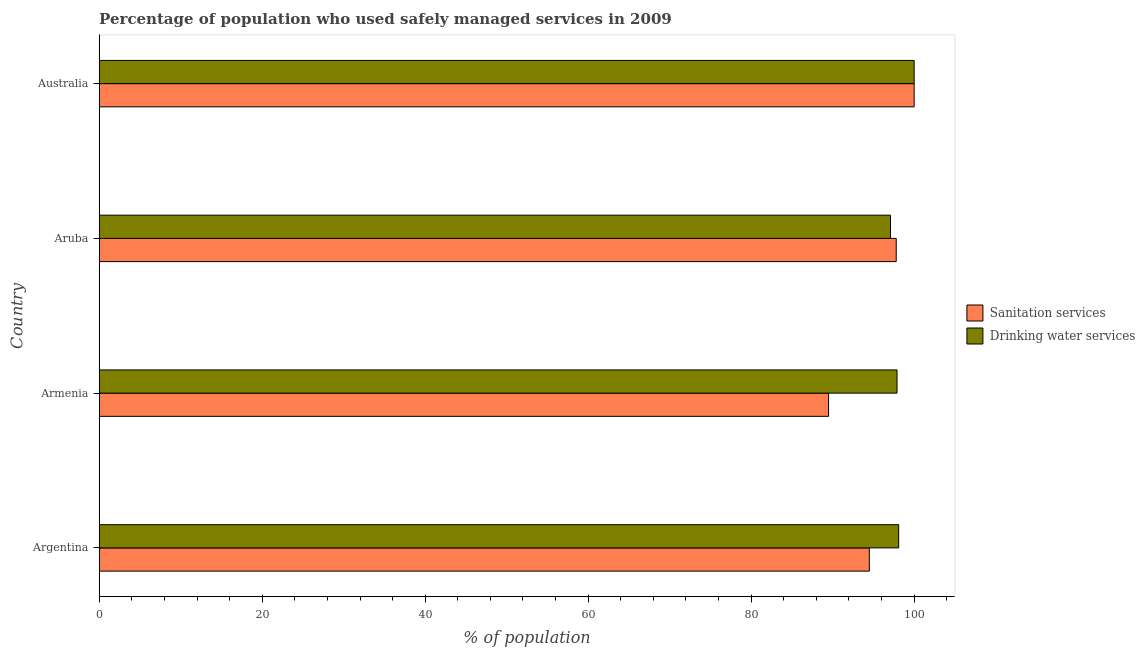How many different coloured bars are there?
Offer a very short reply. 2. Are the number of bars on each tick of the Y-axis equal?
Your response must be concise. Yes. What is the label of the 3rd group of bars from the top?
Provide a short and direct response. Armenia. In how many cases, is the number of bars for a given country not equal to the number of legend labels?
Ensure brevity in your answer.  0. What is the percentage of population who used sanitation services in Armenia?
Provide a short and direct response. 89.5. Across all countries, what is the minimum percentage of population who used sanitation services?
Your answer should be compact. 89.5. In which country was the percentage of population who used drinking water services minimum?
Make the answer very short. Aruba. What is the total percentage of population who used drinking water services in the graph?
Ensure brevity in your answer.  393.1. What is the difference between the percentage of population who used sanitation services in Argentina and the percentage of population who used drinking water services in Armenia?
Ensure brevity in your answer.  -3.4. What is the average percentage of population who used sanitation services per country?
Your response must be concise. 95.45. In how many countries, is the percentage of population who used drinking water services greater than 40 %?
Your answer should be very brief. 4. What is the ratio of the percentage of population who used sanitation services in Armenia to that in Aruba?
Your answer should be very brief. 0.92. Is the percentage of population who used sanitation services in Argentina less than that in Armenia?
Keep it short and to the point. No. What is the difference between the highest and the second highest percentage of population who used sanitation services?
Offer a very short reply. 2.2. What is the difference between the highest and the lowest percentage of population who used drinking water services?
Give a very brief answer. 2.9. In how many countries, is the percentage of population who used sanitation services greater than the average percentage of population who used sanitation services taken over all countries?
Ensure brevity in your answer.  2. What does the 2nd bar from the top in Aruba represents?
Your response must be concise. Sanitation services. What does the 1st bar from the bottom in Argentina represents?
Your answer should be compact. Sanitation services. Are all the bars in the graph horizontal?
Make the answer very short. Yes. Where does the legend appear in the graph?
Offer a terse response. Center right. What is the title of the graph?
Provide a succinct answer. Percentage of population who used safely managed services in 2009. Does "State government" appear as one of the legend labels in the graph?
Your answer should be compact. No. What is the label or title of the X-axis?
Keep it short and to the point. % of population. What is the % of population in Sanitation services in Argentina?
Offer a very short reply. 94.5. What is the % of population of Drinking water services in Argentina?
Provide a short and direct response. 98.1. What is the % of population in Sanitation services in Armenia?
Provide a succinct answer. 89.5. What is the % of population of Drinking water services in Armenia?
Your answer should be compact. 97.9. What is the % of population of Sanitation services in Aruba?
Give a very brief answer. 97.8. What is the % of population of Drinking water services in Aruba?
Your answer should be very brief. 97.1. What is the % of population in Drinking water services in Australia?
Your answer should be compact. 100. Across all countries, what is the maximum % of population in Sanitation services?
Make the answer very short. 100. Across all countries, what is the minimum % of population in Sanitation services?
Offer a very short reply. 89.5. Across all countries, what is the minimum % of population in Drinking water services?
Provide a short and direct response. 97.1. What is the total % of population of Sanitation services in the graph?
Make the answer very short. 381.8. What is the total % of population in Drinking water services in the graph?
Make the answer very short. 393.1. What is the difference between the % of population in Drinking water services in Argentina and that in Armenia?
Your answer should be compact. 0.2. What is the difference between the % of population in Sanitation services in Argentina and that in Australia?
Keep it short and to the point. -5.5. What is the difference between the % of population of Sanitation services in Armenia and that in Aruba?
Make the answer very short. -8.3. What is the difference between the % of population in Drinking water services in Armenia and that in Aruba?
Keep it short and to the point. 0.8. What is the difference between the % of population of Sanitation services in Armenia and that in Australia?
Offer a terse response. -10.5. What is the difference between the % of population in Sanitation services in Argentina and the % of population in Drinking water services in Aruba?
Keep it short and to the point. -2.6. What is the difference between the % of population of Sanitation services in Armenia and the % of population of Drinking water services in Australia?
Provide a succinct answer. -10.5. What is the average % of population in Sanitation services per country?
Provide a succinct answer. 95.45. What is the average % of population in Drinking water services per country?
Offer a very short reply. 98.28. What is the difference between the % of population of Sanitation services and % of population of Drinking water services in Armenia?
Ensure brevity in your answer.  -8.4. What is the difference between the % of population in Sanitation services and % of population in Drinking water services in Australia?
Make the answer very short. 0. What is the ratio of the % of population of Sanitation services in Argentina to that in Armenia?
Give a very brief answer. 1.06. What is the ratio of the % of population of Drinking water services in Argentina to that in Armenia?
Keep it short and to the point. 1. What is the ratio of the % of population of Sanitation services in Argentina to that in Aruba?
Provide a succinct answer. 0.97. What is the ratio of the % of population in Drinking water services in Argentina to that in Aruba?
Offer a very short reply. 1.01. What is the ratio of the % of population of Sanitation services in Argentina to that in Australia?
Offer a very short reply. 0.94. What is the ratio of the % of population of Drinking water services in Argentina to that in Australia?
Offer a very short reply. 0.98. What is the ratio of the % of population of Sanitation services in Armenia to that in Aruba?
Provide a succinct answer. 0.92. What is the ratio of the % of population of Drinking water services in Armenia to that in Aruba?
Your response must be concise. 1.01. What is the ratio of the % of population of Sanitation services in Armenia to that in Australia?
Your answer should be compact. 0.9. What is the difference between the highest and the second highest % of population of Sanitation services?
Provide a short and direct response. 2.2. What is the difference between the highest and the lowest % of population of Sanitation services?
Offer a terse response. 10.5. 